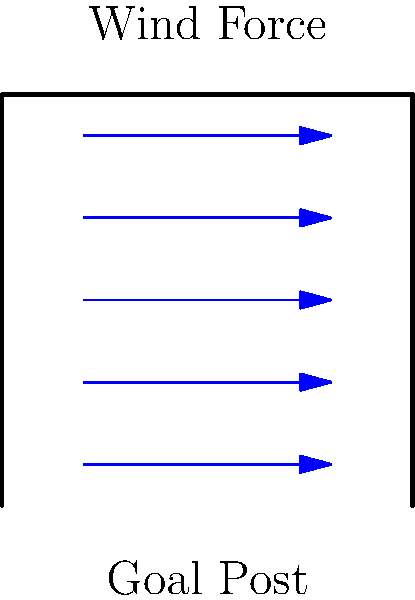At your local high school's football field, you notice the goal posts swaying during a particularly windy game. If the wind speed is 30 mph and the goal post is 30 feet tall, what is the approximate lateral force (in pounds) acting on the goal post, assuming a drag coefficient of 1.2 and air density of 0.075 lb/ft³? To calculate the lateral force on the goal post due to wind, we'll use the drag force equation:

1. The drag force equation is:
   $F = \frac{1}{2} \cdot C_d \cdot \rho \cdot A \cdot v^2$

   Where:
   $F$ = Force (lb)
   $C_d$ = Drag coefficient (given as 1.2)
   $\rho$ = Air density (given as 0.075 lb/ft³)
   $A$ = Projected area (ft²)
   $v$ = Wind velocity (ft/s)

2. Convert wind speed from mph to ft/s:
   30 mph = 30 * 5280 / 3600 = 44 ft/s

3. Estimate the projected area:
   Assuming the goal post is 6 inches wide:
   $A = 30 \text{ ft} \cdot 0.5 \text{ ft} = 15 \text{ ft}^2$

4. Plug values into the equation:
   $F = \frac{1}{2} \cdot 1.2 \cdot 0.075 \text{ lb/ft}^3 \cdot 15 \text{ ft}^2 \cdot (44 \text{ ft/s})^2$

5. Calculate:
   $F = 0.5 \cdot 1.2 \cdot 0.075 \cdot 15 \cdot 1936 = 130.68 \text{ lb}$

6. Round to the nearest whole number:
   $F \approx 131 \text{ lb}$
Answer: 131 lb 